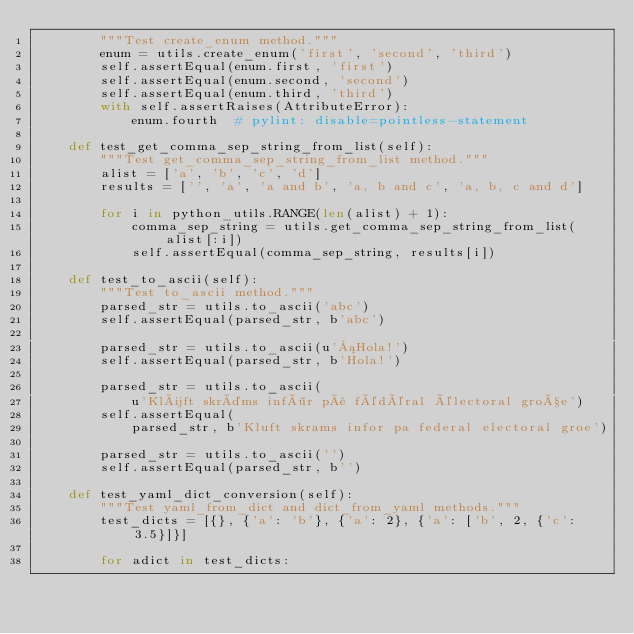<code> <loc_0><loc_0><loc_500><loc_500><_Python_>        """Test create_enum method."""
        enum = utils.create_enum('first', 'second', 'third')
        self.assertEqual(enum.first, 'first')
        self.assertEqual(enum.second, 'second')
        self.assertEqual(enum.third, 'third')
        with self.assertRaises(AttributeError):
            enum.fourth  # pylint: disable=pointless-statement

    def test_get_comma_sep_string_from_list(self):
        """Test get_comma_sep_string_from_list method."""
        alist = ['a', 'b', 'c', 'd']
        results = ['', 'a', 'a and b', 'a, b and c', 'a, b, c and d']

        for i in python_utils.RANGE(len(alist) + 1):
            comma_sep_string = utils.get_comma_sep_string_from_list(alist[:i])
            self.assertEqual(comma_sep_string, results[i])

    def test_to_ascii(self):
        """Test to_ascii method."""
        parsed_str = utils.to_ascii('abc')
        self.assertEqual(parsed_str, b'abc')

        parsed_str = utils.to_ascii(u'¡Hola!')
        self.assertEqual(parsed_str, b'Hola!')

        parsed_str = utils.to_ascii(
            u'Klüft skräms inför på fédéral électoral große')
        self.assertEqual(
            parsed_str, b'Kluft skrams infor pa federal electoral groe')

        parsed_str = utils.to_ascii('')
        self.assertEqual(parsed_str, b'')

    def test_yaml_dict_conversion(self):
        """Test yaml_from_dict and dict_from_yaml methods."""
        test_dicts = [{}, {'a': 'b'}, {'a': 2}, {'a': ['b', 2, {'c': 3.5}]}]

        for adict in test_dicts:</code> 